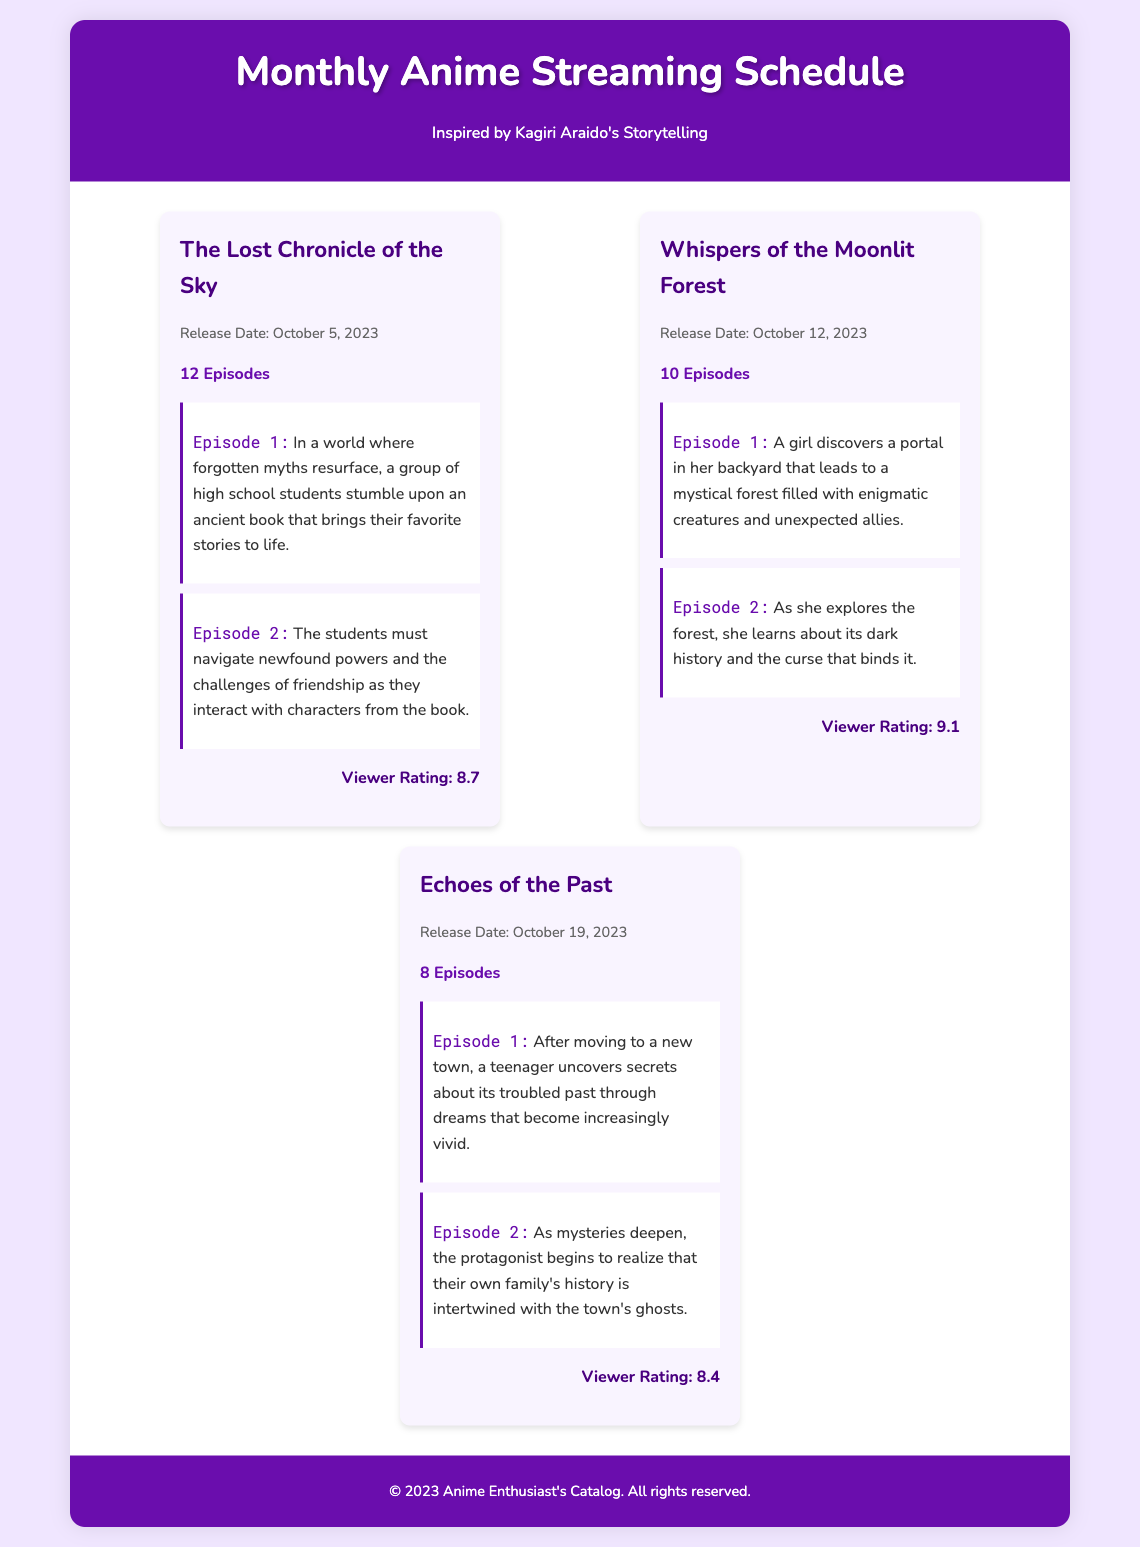What is the title of the anime with the highest viewer rating? The anime with the highest viewer rating is "Whispers of the Moonlit Forest," which has a rating of 9.1.
Answer: Whispers of the Moonlit Forest When is the release date of "The Lost Chronicle of the Sky"? The release date for "The Lost Chronicle of the Sky" is October 5, 2023.
Answer: October 5, 2023 How many episodes does "Echoes of the Past" have? "Echoes of the Past" has a total of 8 episodes as specified in the document.
Answer: 8 Episodes What is the viewer rating for "Whispers of the Moonlit Forest"? The viewer rating for "Whispers of the Moonlit Forest" is mentioned in the document as 9.1.
Answer: 9.1 In which episode do the students navigate newfound powers? The students navigate newfound powers in Episode 2 of "The Lost Chronicle of the Sky."
Answer: Episode 2 What is the release date for "Echoes of the Past"? The release date for "Echoes of the Past" is October 19, 2023.
Answer: October 19, 2023 Which anime features a protagonist discovering a portal in her backyard? The anime featuring a protagonist discovering a portal in her backyard is "Whispers of the Moonlit Forest."
Answer: Whispers of the Moonlit Forest How many episodes are scheduled for "Whispers of the Moonlit Forest"? "Whispers of the Moonlit Forest" is scheduled for 10 episodes as stated in the schedule.
Answer: 10 Episodes 